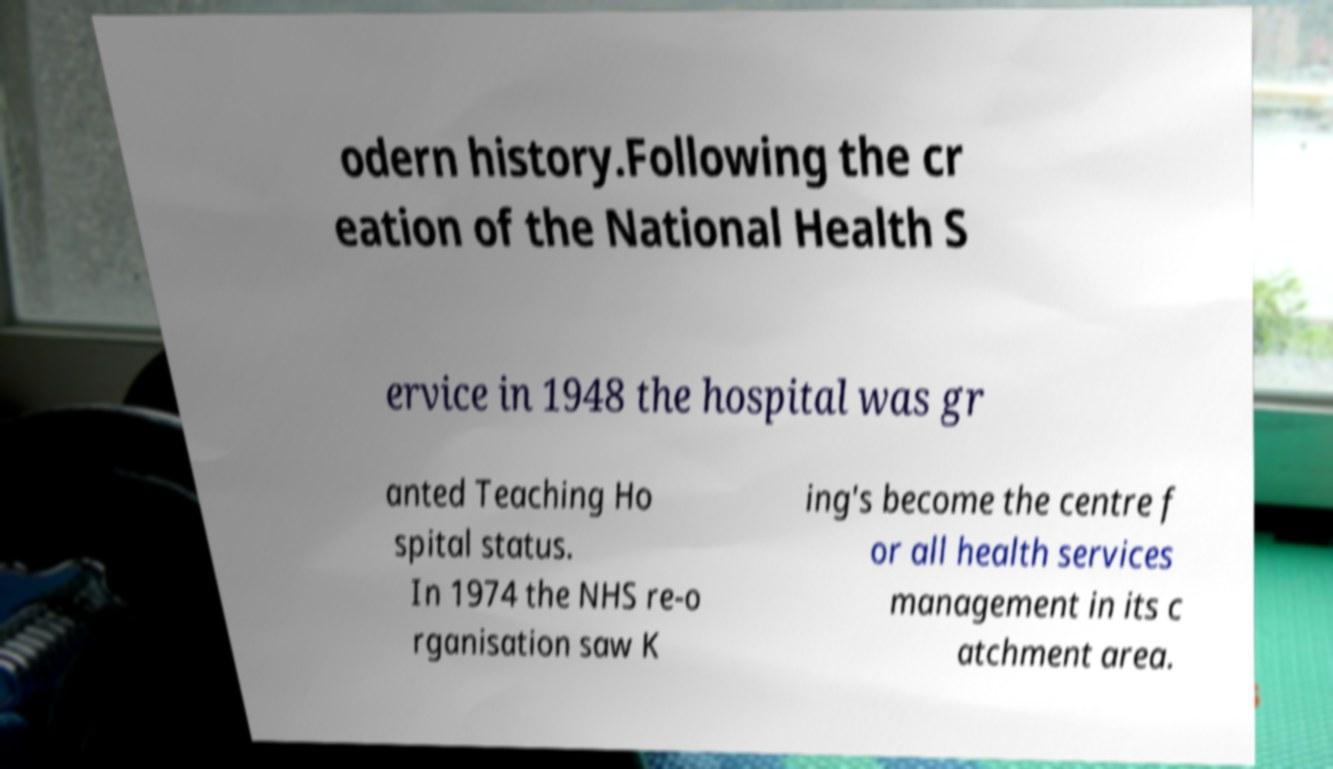I need the written content from this picture converted into text. Can you do that? odern history.Following the cr eation of the National Health S ervice in 1948 the hospital was gr anted Teaching Ho spital status. In 1974 the NHS re-o rganisation saw K ing's become the centre f or all health services management in its c atchment area. 